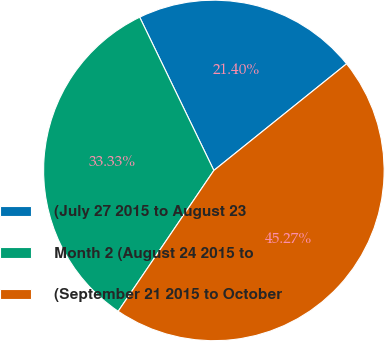Convert chart to OTSL. <chart><loc_0><loc_0><loc_500><loc_500><pie_chart><fcel>(July 27 2015 to August 23<fcel>Month 2 (August 24 2015 to<fcel>(September 21 2015 to October<nl><fcel>21.4%<fcel>33.33%<fcel>45.27%<nl></chart> 